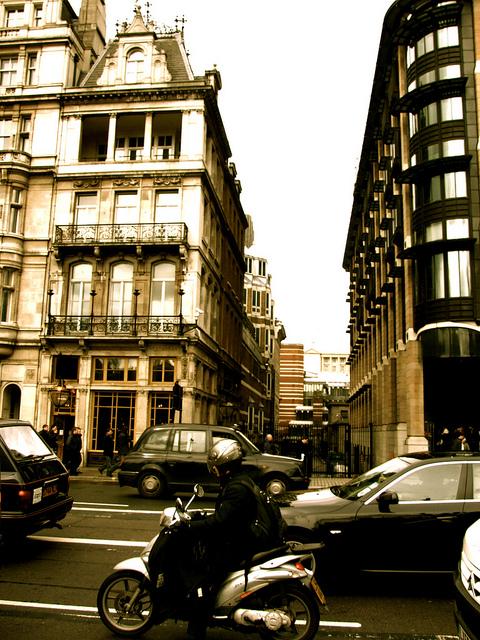Do you think the photo is done in black and white or sepia coloration?
Be succinct. Sepia. How many cars are in the scene?
Be succinct. 3. What city is this in?
Answer briefly. London. 